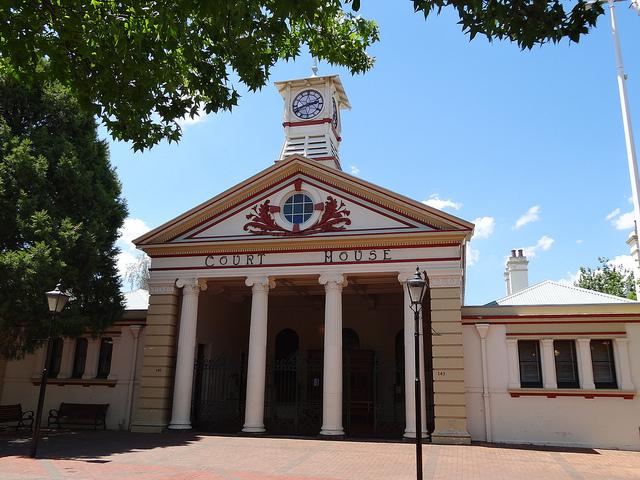What time is it in the picture?
Quick response, please. 2:40. What number of pillars are holding up this building?
Quick response, please. 4. Is this a courthouse?
Quick response, please. Yes. 